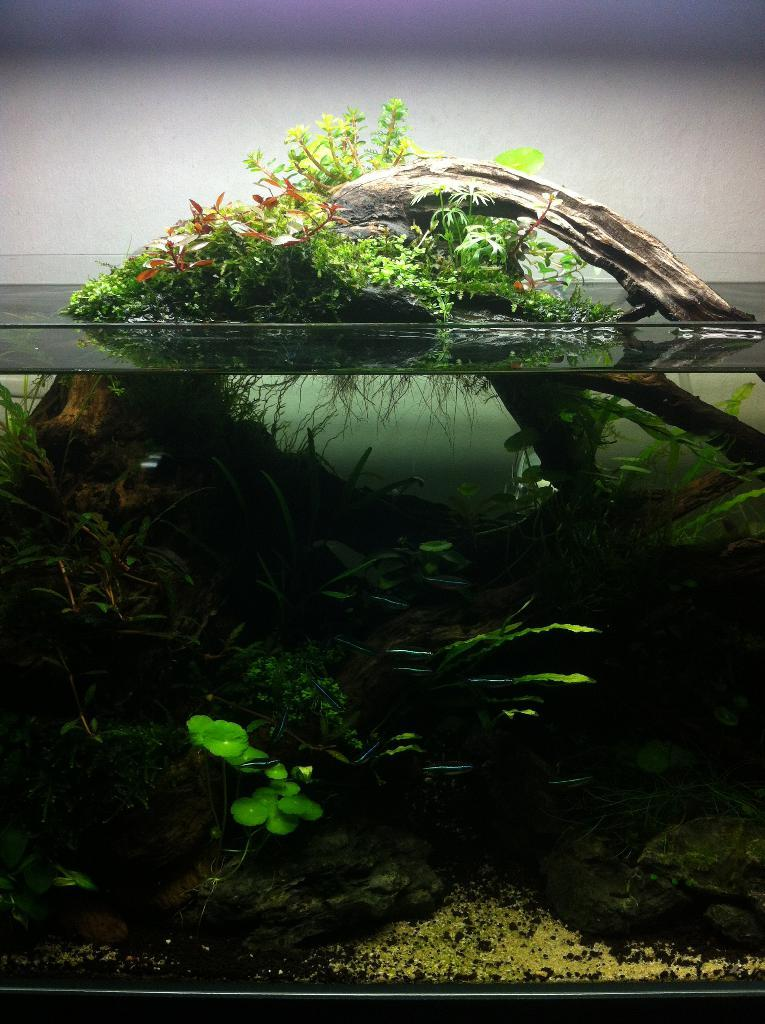What is the main subject in the center of the image? There is an aquarium in the center of the image. What can be found inside the aquarium? The aquarium contains plants, water, and other objects. What is visible in the background of the image? There is a wall in the background of the image. What type of pet can be seen interacting with the owner in the image? There is no pet or owner present in the image; it features an aquarium with plants, water, and other objects. What type of fang is visible in the image? There is no fang present in the image. 